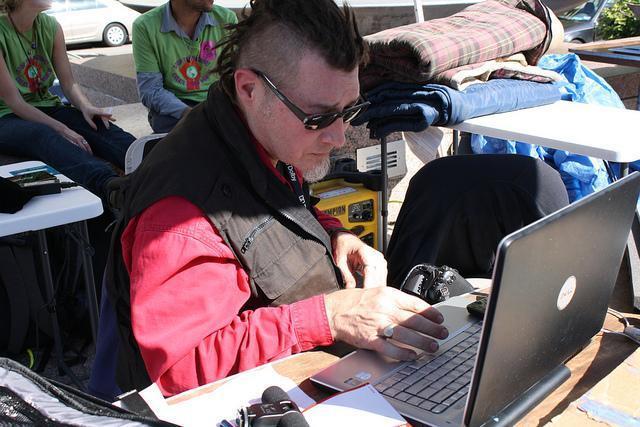How many people are there?
Give a very brief answer. 3. 